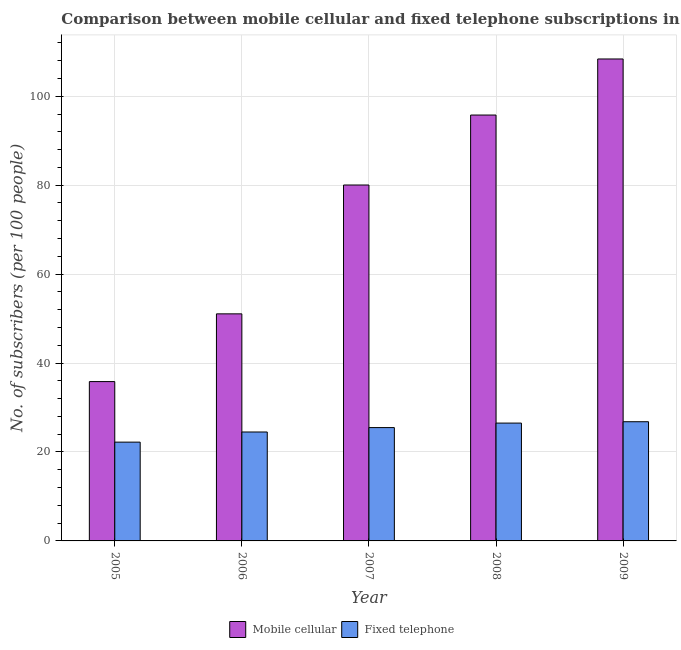How many groups of bars are there?
Your answer should be very brief. 5. What is the label of the 1st group of bars from the left?
Provide a short and direct response. 2005. What is the number of fixed telephone subscribers in 2006?
Ensure brevity in your answer.  24.5. Across all years, what is the maximum number of mobile cellular subscribers?
Make the answer very short. 108.38. Across all years, what is the minimum number of fixed telephone subscribers?
Keep it short and to the point. 22.21. In which year was the number of mobile cellular subscribers minimum?
Provide a short and direct response. 2005. What is the total number of mobile cellular subscribers in the graph?
Your answer should be very brief. 371.09. What is the difference between the number of mobile cellular subscribers in 2006 and that in 2007?
Offer a very short reply. -28.97. What is the difference between the number of mobile cellular subscribers in 2005 and the number of fixed telephone subscribers in 2009?
Provide a short and direct response. -72.55. What is the average number of fixed telephone subscribers per year?
Keep it short and to the point. 25.1. In the year 2008, what is the difference between the number of fixed telephone subscribers and number of mobile cellular subscribers?
Offer a terse response. 0. In how many years, is the number of fixed telephone subscribers greater than 52?
Your answer should be compact. 0. What is the ratio of the number of fixed telephone subscribers in 2005 to that in 2009?
Ensure brevity in your answer.  0.83. Is the number of mobile cellular subscribers in 2005 less than that in 2006?
Offer a terse response. Yes. Is the difference between the number of mobile cellular subscribers in 2008 and 2009 greater than the difference between the number of fixed telephone subscribers in 2008 and 2009?
Make the answer very short. No. What is the difference between the highest and the second highest number of mobile cellular subscribers?
Offer a very short reply. 12.61. What is the difference between the highest and the lowest number of mobile cellular subscribers?
Provide a short and direct response. 72.55. In how many years, is the number of fixed telephone subscribers greater than the average number of fixed telephone subscribers taken over all years?
Offer a terse response. 3. What does the 2nd bar from the left in 2005 represents?
Offer a terse response. Fixed telephone. What does the 1st bar from the right in 2006 represents?
Provide a short and direct response. Fixed telephone. Are the values on the major ticks of Y-axis written in scientific E-notation?
Provide a short and direct response. No. Does the graph contain any zero values?
Offer a terse response. No. Where does the legend appear in the graph?
Give a very brief answer. Bottom center. What is the title of the graph?
Your answer should be very brief. Comparison between mobile cellular and fixed telephone subscriptions in Kazakhstan. Does "Formally registered" appear as one of the legend labels in the graph?
Your answer should be very brief. No. What is the label or title of the Y-axis?
Offer a terse response. No. of subscribers (per 100 people). What is the No. of subscribers (per 100 people) of Mobile cellular in 2005?
Ensure brevity in your answer.  35.83. What is the No. of subscribers (per 100 people) in Fixed telephone in 2005?
Offer a very short reply. 22.21. What is the No. of subscribers (per 100 people) in Mobile cellular in 2006?
Make the answer very short. 51.06. What is the No. of subscribers (per 100 people) of Fixed telephone in 2006?
Provide a short and direct response. 24.5. What is the No. of subscribers (per 100 people) of Mobile cellular in 2007?
Your answer should be compact. 80.04. What is the No. of subscribers (per 100 people) of Fixed telephone in 2007?
Provide a short and direct response. 25.49. What is the No. of subscribers (per 100 people) of Mobile cellular in 2008?
Offer a terse response. 95.78. What is the No. of subscribers (per 100 people) of Fixed telephone in 2008?
Your answer should be compact. 26.5. What is the No. of subscribers (per 100 people) of Mobile cellular in 2009?
Your answer should be compact. 108.38. What is the No. of subscribers (per 100 people) of Fixed telephone in 2009?
Offer a terse response. 26.8. Across all years, what is the maximum No. of subscribers (per 100 people) in Mobile cellular?
Your response must be concise. 108.38. Across all years, what is the maximum No. of subscribers (per 100 people) of Fixed telephone?
Offer a very short reply. 26.8. Across all years, what is the minimum No. of subscribers (per 100 people) of Mobile cellular?
Your response must be concise. 35.83. Across all years, what is the minimum No. of subscribers (per 100 people) in Fixed telephone?
Provide a succinct answer. 22.21. What is the total No. of subscribers (per 100 people) of Mobile cellular in the graph?
Keep it short and to the point. 371.09. What is the total No. of subscribers (per 100 people) of Fixed telephone in the graph?
Provide a short and direct response. 125.5. What is the difference between the No. of subscribers (per 100 people) of Mobile cellular in 2005 and that in 2006?
Keep it short and to the point. -15.23. What is the difference between the No. of subscribers (per 100 people) in Fixed telephone in 2005 and that in 2006?
Your answer should be compact. -2.28. What is the difference between the No. of subscribers (per 100 people) of Mobile cellular in 2005 and that in 2007?
Provide a succinct answer. -44.2. What is the difference between the No. of subscribers (per 100 people) in Fixed telephone in 2005 and that in 2007?
Your response must be concise. -3.27. What is the difference between the No. of subscribers (per 100 people) in Mobile cellular in 2005 and that in 2008?
Make the answer very short. -59.94. What is the difference between the No. of subscribers (per 100 people) in Fixed telephone in 2005 and that in 2008?
Ensure brevity in your answer.  -4.28. What is the difference between the No. of subscribers (per 100 people) in Mobile cellular in 2005 and that in 2009?
Your answer should be very brief. -72.55. What is the difference between the No. of subscribers (per 100 people) of Fixed telephone in 2005 and that in 2009?
Your response must be concise. -4.59. What is the difference between the No. of subscribers (per 100 people) in Mobile cellular in 2006 and that in 2007?
Ensure brevity in your answer.  -28.97. What is the difference between the No. of subscribers (per 100 people) in Fixed telephone in 2006 and that in 2007?
Offer a terse response. -0.99. What is the difference between the No. of subscribers (per 100 people) in Mobile cellular in 2006 and that in 2008?
Keep it short and to the point. -44.71. What is the difference between the No. of subscribers (per 100 people) of Fixed telephone in 2006 and that in 2008?
Your answer should be compact. -2. What is the difference between the No. of subscribers (per 100 people) of Mobile cellular in 2006 and that in 2009?
Your answer should be compact. -57.32. What is the difference between the No. of subscribers (per 100 people) of Fixed telephone in 2006 and that in 2009?
Give a very brief answer. -2.31. What is the difference between the No. of subscribers (per 100 people) of Mobile cellular in 2007 and that in 2008?
Your response must be concise. -15.74. What is the difference between the No. of subscribers (per 100 people) of Fixed telephone in 2007 and that in 2008?
Your response must be concise. -1.01. What is the difference between the No. of subscribers (per 100 people) in Mobile cellular in 2007 and that in 2009?
Make the answer very short. -28.34. What is the difference between the No. of subscribers (per 100 people) in Fixed telephone in 2007 and that in 2009?
Your answer should be very brief. -1.32. What is the difference between the No. of subscribers (per 100 people) of Mobile cellular in 2008 and that in 2009?
Your answer should be compact. -12.61. What is the difference between the No. of subscribers (per 100 people) of Fixed telephone in 2008 and that in 2009?
Your response must be concise. -0.31. What is the difference between the No. of subscribers (per 100 people) in Mobile cellular in 2005 and the No. of subscribers (per 100 people) in Fixed telephone in 2006?
Your response must be concise. 11.34. What is the difference between the No. of subscribers (per 100 people) in Mobile cellular in 2005 and the No. of subscribers (per 100 people) in Fixed telephone in 2007?
Offer a terse response. 10.35. What is the difference between the No. of subscribers (per 100 people) of Mobile cellular in 2005 and the No. of subscribers (per 100 people) of Fixed telephone in 2008?
Make the answer very short. 9.33. What is the difference between the No. of subscribers (per 100 people) of Mobile cellular in 2005 and the No. of subscribers (per 100 people) of Fixed telephone in 2009?
Offer a very short reply. 9.03. What is the difference between the No. of subscribers (per 100 people) of Mobile cellular in 2006 and the No. of subscribers (per 100 people) of Fixed telephone in 2007?
Your answer should be very brief. 25.58. What is the difference between the No. of subscribers (per 100 people) in Mobile cellular in 2006 and the No. of subscribers (per 100 people) in Fixed telephone in 2008?
Provide a short and direct response. 24.57. What is the difference between the No. of subscribers (per 100 people) of Mobile cellular in 2006 and the No. of subscribers (per 100 people) of Fixed telephone in 2009?
Give a very brief answer. 24.26. What is the difference between the No. of subscribers (per 100 people) in Mobile cellular in 2007 and the No. of subscribers (per 100 people) in Fixed telephone in 2008?
Your answer should be compact. 53.54. What is the difference between the No. of subscribers (per 100 people) in Mobile cellular in 2007 and the No. of subscribers (per 100 people) in Fixed telephone in 2009?
Keep it short and to the point. 53.23. What is the difference between the No. of subscribers (per 100 people) of Mobile cellular in 2008 and the No. of subscribers (per 100 people) of Fixed telephone in 2009?
Your response must be concise. 68.97. What is the average No. of subscribers (per 100 people) of Mobile cellular per year?
Offer a terse response. 74.22. What is the average No. of subscribers (per 100 people) of Fixed telephone per year?
Keep it short and to the point. 25.1. In the year 2005, what is the difference between the No. of subscribers (per 100 people) in Mobile cellular and No. of subscribers (per 100 people) in Fixed telephone?
Your answer should be very brief. 13.62. In the year 2006, what is the difference between the No. of subscribers (per 100 people) in Mobile cellular and No. of subscribers (per 100 people) in Fixed telephone?
Provide a succinct answer. 26.57. In the year 2007, what is the difference between the No. of subscribers (per 100 people) of Mobile cellular and No. of subscribers (per 100 people) of Fixed telephone?
Your response must be concise. 54.55. In the year 2008, what is the difference between the No. of subscribers (per 100 people) in Mobile cellular and No. of subscribers (per 100 people) in Fixed telephone?
Provide a succinct answer. 69.28. In the year 2009, what is the difference between the No. of subscribers (per 100 people) of Mobile cellular and No. of subscribers (per 100 people) of Fixed telephone?
Your answer should be very brief. 81.58. What is the ratio of the No. of subscribers (per 100 people) in Mobile cellular in 2005 to that in 2006?
Your response must be concise. 0.7. What is the ratio of the No. of subscribers (per 100 people) of Fixed telephone in 2005 to that in 2006?
Give a very brief answer. 0.91. What is the ratio of the No. of subscribers (per 100 people) of Mobile cellular in 2005 to that in 2007?
Give a very brief answer. 0.45. What is the ratio of the No. of subscribers (per 100 people) of Fixed telephone in 2005 to that in 2007?
Ensure brevity in your answer.  0.87. What is the ratio of the No. of subscribers (per 100 people) in Mobile cellular in 2005 to that in 2008?
Provide a short and direct response. 0.37. What is the ratio of the No. of subscribers (per 100 people) in Fixed telephone in 2005 to that in 2008?
Ensure brevity in your answer.  0.84. What is the ratio of the No. of subscribers (per 100 people) in Mobile cellular in 2005 to that in 2009?
Make the answer very short. 0.33. What is the ratio of the No. of subscribers (per 100 people) of Fixed telephone in 2005 to that in 2009?
Give a very brief answer. 0.83. What is the ratio of the No. of subscribers (per 100 people) in Mobile cellular in 2006 to that in 2007?
Make the answer very short. 0.64. What is the ratio of the No. of subscribers (per 100 people) in Fixed telephone in 2006 to that in 2007?
Your response must be concise. 0.96. What is the ratio of the No. of subscribers (per 100 people) in Mobile cellular in 2006 to that in 2008?
Ensure brevity in your answer.  0.53. What is the ratio of the No. of subscribers (per 100 people) in Fixed telephone in 2006 to that in 2008?
Provide a short and direct response. 0.92. What is the ratio of the No. of subscribers (per 100 people) in Mobile cellular in 2006 to that in 2009?
Offer a terse response. 0.47. What is the ratio of the No. of subscribers (per 100 people) of Fixed telephone in 2006 to that in 2009?
Offer a very short reply. 0.91. What is the ratio of the No. of subscribers (per 100 people) in Mobile cellular in 2007 to that in 2008?
Your response must be concise. 0.84. What is the ratio of the No. of subscribers (per 100 people) of Fixed telephone in 2007 to that in 2008?
Give a very brief answer. 0.96. What is the ratio of the No. of subscribers (per 100 people) in Mobile cellular in 2007 to that in 2009?
Your answer should be very brief. 0.74. What is the ratio of the No. of subscribers (per 100 people) of Fixed telephone in 2007 to that in 2009?
Ensure brevity in your answer.  0.95. What is the ratio of the No. of subscribers (per 100 people) in Mobile cellular in 2008 to that in 2009?
Offer a very short reply. 0.88. What is the difference between the highest and the second highest No. of subscribers (per 100 people) in Mobile cellular?
Your response must be concise. 12.61. What is the difference between the highest and the second highest No. of subscribers (per 100 people) in Fixed telephone?
Offer a very short reply. 0.31. What is the difference between the highest and the lowest No. of subscribers (per 100 people) of Mobile cellular?
Keep it short and to the point. 72.55. What is the difference between the highest and the lowest No. of subscribers (per 100 people) of Fixed telephone?
Offer a terse response. 4.59. 